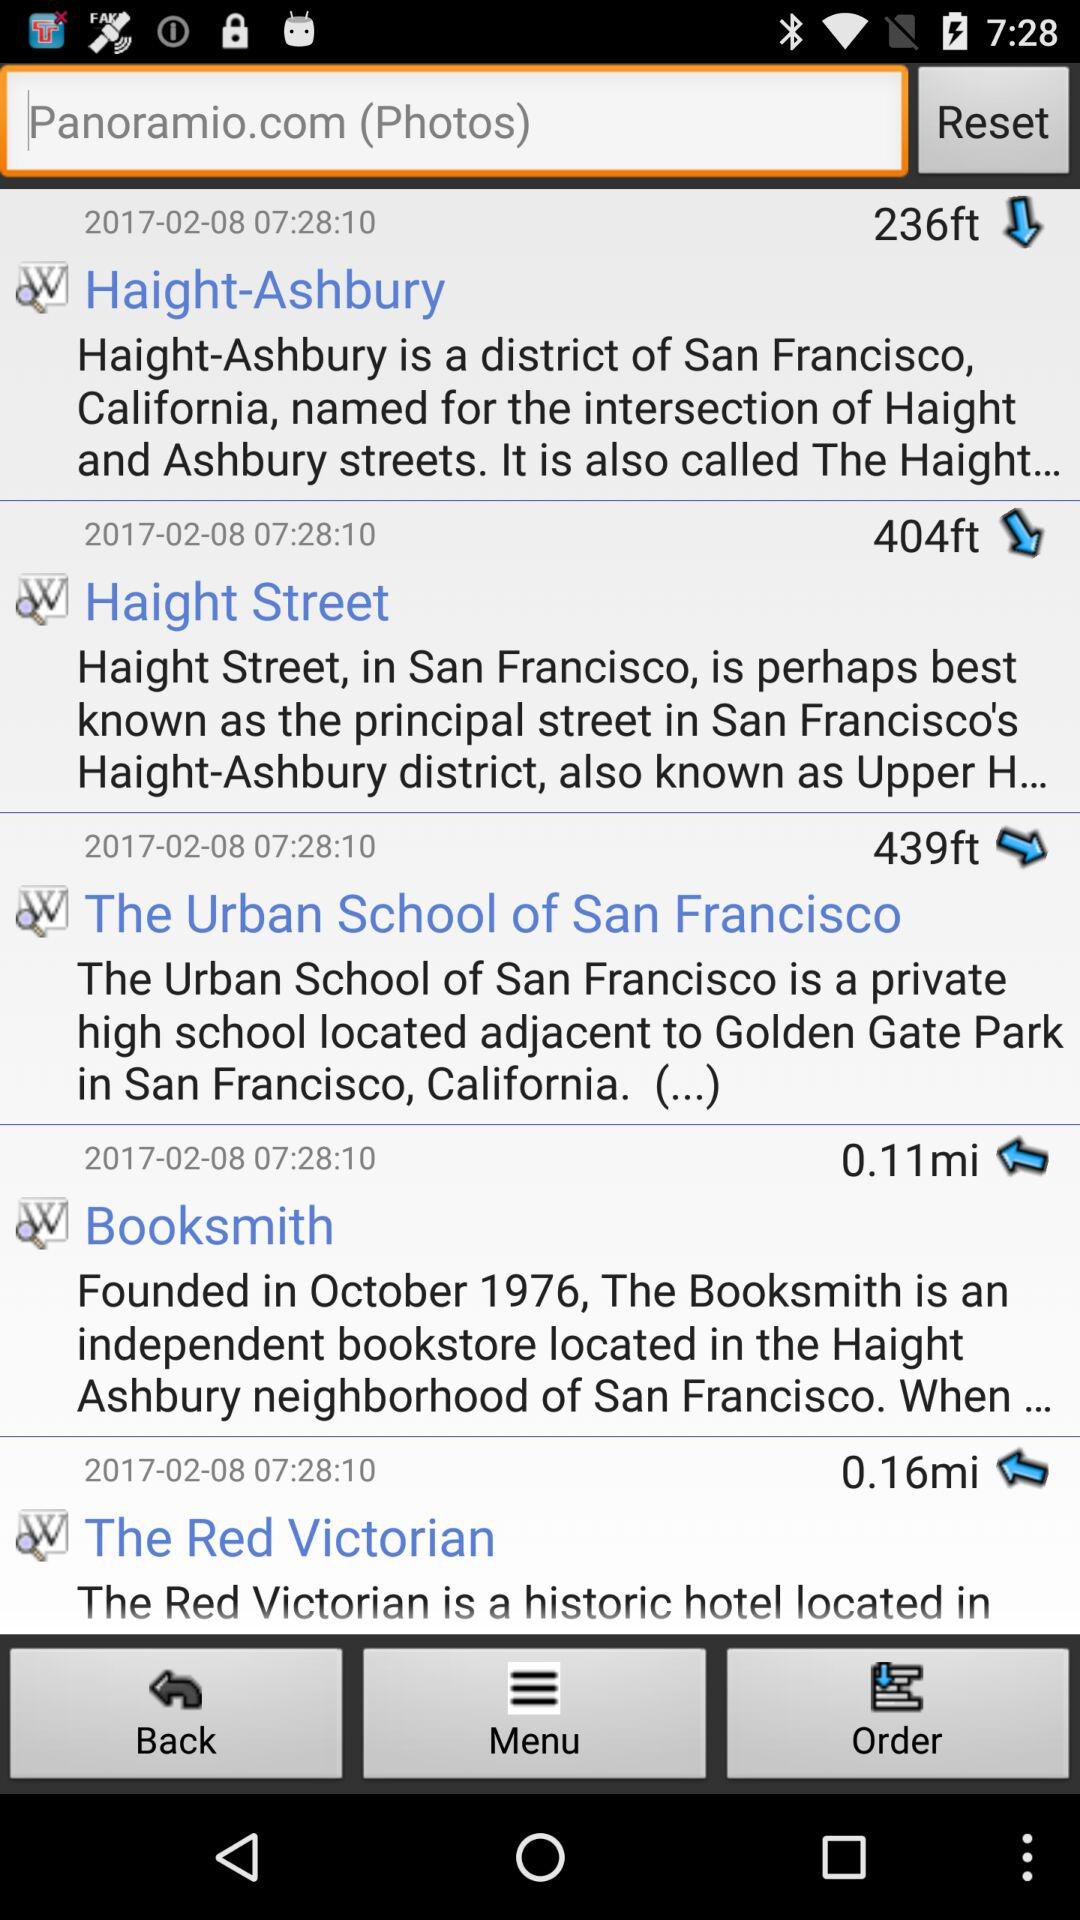What is the date and time shown on the screen? The date is February 8, 2017 and the time is 07:28:10. 